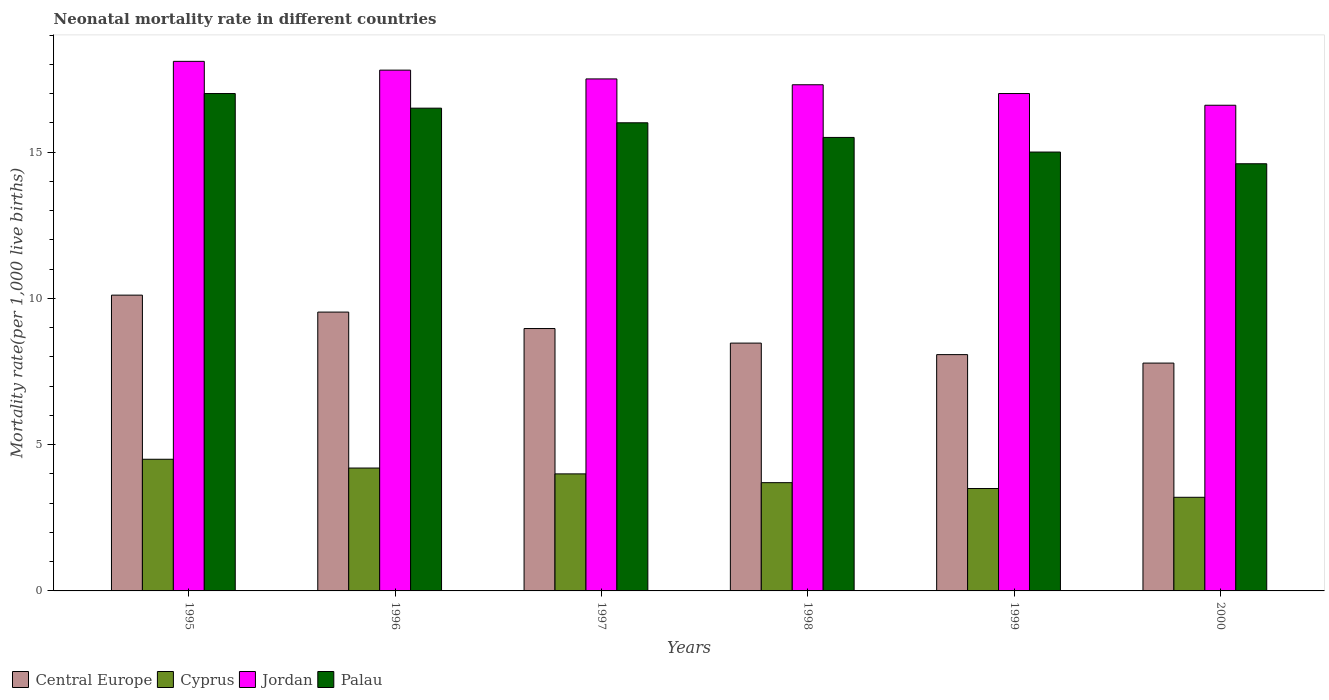How many different coloured bars are there?
Ensure brevity in your answer.  4. How many groups of bars are there?
Give a very brief answer. 6. Are the number of bars on each tick of the X-axis equal?
Make the answer very short. Yes. How many bars are there on the 6th tick from the left?
Provide a short and direct response. 4. What is the label of the 2nd group of bars from the left?
Provide a short and direct response. 1996. In how many cases, is the number of bars for a given year not equal to the number of legend labels?
Give a very brief answer. 0. What is the neonatal mortality rate in Jordan in 1999?
Make the answer very short. 17. Across all years, what is the minimum neonatal mortality rate in Jordan?
Your response must be concise. 16.6. In which year was the neonatal mortality rate in Jordan minimum?
Your answer should be very brief. 2000. What is the total neonatal mortality rate in Cyprus in the graph?
Provide a succinct answer. 23.1. What is the difference between the neonatal mortality rate in Palau in 1996 and that in 1997?
Offer a very short reply. 0.5. What is the difference between the neonatal mortality rate in Central Europe in 2000 and the neonatal mortality rate in Jordan in 1998?
Your answer should be compact. -9.51. What is the average neonatal mortality rate in Palau per year?
Keep it short and to the point. 15.77. In the year 2000, what is the difference between the neonatal mortality rate in Palau and neonatal mortality rate in Central Europe?
Offer a very short reply. 6.81. In how many years, is the neonatal mortality rate in Central Europe greater than 16?
Your answer should be compact. 0. What is the ratio of the neonatal mortality rate in Jordan in 1998 to that in 2000?
Your response must be concise. 1.04. Is the neonatal mortality rate in Cyprus in 1995 less than that in 1996?
Your answer should be compact. No. Is the difference between the neonatal mortality rate in Palau in 1999 and 2000 greater than the difference between the neonatal mortality rate in Central Europe in 1999 and 2000?
Your answer should be very brief. Yes. What is the difference between the highest and the second highest neonatal mortality rate in Palau?
Provide a succinct answer. 0.5. What is the difference between the highest and the lowest neonatal mortality rate in Palau?
Provide a succinct answer. 2.4. Is the sum of the neonatal mortality rate in Jordan in 1998 and 1999 greater than the maximum neonatal mortality rate in Cyprus across all years?
Offer a very short reply. Yes. Is it the case that in every year, the sum of the neonatal mortality rate in Cyprus and neonatal mortality rate in Central Europe is greater than the sum of neonatal mortality rate in Jordan and neonatal mortality rate in Palau?
Ensure brevity in your answer.  No. What does the 3rd bar from the left in 1998 represents?
Provide a succinct answer. Jordan. What does the 3rd bar from the right in 2000 represents?
Your answer should be compact. Cyprus. Is it the case that in every year, the sum of the neonatal mortality rate in Central Europe and neonatal mortality rate in Cyprus is greater than the neonatal mortality rate in Palau?
Offer a terse response. No. Are all the bars in the graph horizontal?
Make the answer very short. No. How many legend labels are there?
Offer a terse response. 4. What is the title of the graph?
Make the answer very short. Neonatal mortality rate in different countries. What is the label or title of the Y-axis?
Provide a short and direct response. Mortality rate(per 1,0 live births). What is the Mortality rate(per 1,000 live births) in Central Europe in 1995?
Provide a succinct answer. 10.11. What is the Mortality rate(per 1,000 live births) in Cyprus in 1995?
Provide a succinct answer. 4.5. What is the Mortality rate(per 1,000 live births) of Jordan in 1995?
Give a very brief answer. 18.1. What is the Mortality rate(per 1,000 live births) in Central Europe in 1996?
Your answer should be compact. 9.53. What is the Mortality rate(per 1,000 live births) of Jordan in 1996?
Make the answer very short. 17.8. What is the Mortality rate(per 1,000 live births) in Central Europe in 1997?
Offer a terse response. 8.97. What is the Mortality rate(per 1,000 live births) of Cyprus in 1997?
Provide a succinct answer. 4. What is the Mortality rate(per 1,000 live births) of Jordan in 1997?
Ensure brevity in your answer.  17.5. What is the Mortality rate(per 1,000 live births) of Palau in 1997?
Make the answer very short. 16. What is the Mortality rate(per 1,000 live births) of Central Europe in 1998?
Offer a terse response. 8.47. What is the Mortality rate(per 1,000 live births) in Cyprus in 1998?
Ensure brevity in your answer.  3.7. What is the Mortality rate(per 1,000 live births) of Jordan in 1998?
Your answer should be very brief. 17.3. What is the Mortality rate(per 1,000 live births) in Central Europe in 1999?
Your answer should be very brief. 8.08. What is the Mortality rate(per 1,000 live births) of Palau in 1999?
Your answer should be compact. 15. What is the Mortality rate(per 1,000 live births) of Central Europe in 2000?
Give a very brief answer. 7.79. What is the Mortality rate(per 1,000 live births) in Cyprus in 2000?
Your answer should be very brief. 3.2. What is the Mortality rate(per 1,000 live births) in Jordan in 2000?
Offer a terse response. 16.6. What is the Mortality rate(per 1,000 live births) in Palau in 2000?
Ensure brevity in your answer.  14.6. Across all years, what is the maximum Mortality rate(per 1,000 live births) of Central Europe?
Provide a succinct answer. 10.11. Across all years, what is the maximum Mortality rate(per 1,000 live births) in Palau?
Your answer should be compact. 17. Across all years, what is the minimum Mortality rate(per 1,000 live births) in Central Europe?
Give a very brief answer. 7.79. Across all years, what is the minimum Mortality rate(per 1,000 live births) in Palau?
Keep it short and to the point. 14.6. What is the total Mortality rate(per 1,000 live births) in Central Europe in the graph?
Provide a short and direct response. 52.94. What is the total Mortality rate(per 1,000 live births) in Cyprus in the graph?
Keep it short and to the point. 23.1. What is the total Mortality rate(per 1,000 live births) of Jordan in the graph?
Keep it short and to the point. 104.3. What is the total Mortality rate(per 1,000 live births) in Palau in the graph?
Your answer should be very brief. 94.6. What is the difference between the Mortality rate(per 1,000 live births) in Central Europe in 1995 and that in 1996?
Your answer should be very brief. 0.58. What is the difference between the Mortality rate(per 1,000 live births) of Cyprus in 1995 and that in 1996?
Your answer should be compact. 0.3. What is the difference between the Mortality rate(per 1,000 live births) of Palau in 1995 and that in 1996?
Provide a succinct answer. 0.5. What is the difference between the Mortality rate(per 1,000 live births) of Central Europe in 1995 and that in 1997?
Offer a terse response. 1.14. What is the difference between the Mortality rate(per 1,000 live births) in Cyprus in 1995 and that in 1997?
Your answer should be compact. 0.5. What is the difference between the Mortality rate(per 1,000 live births) of Jordan in 1995 and that in 1997?
Make the answer very short. 0.6. What is the difference between the Mortality rate(per 1,000 live births) in Palau in 1995 and that in 1997?
Make the answer very short. 1. What is the difference between the Mortality rate(per 1,000 live births) in Central Europe in 1995 and that in 1998?
Provide a short and direct response. 1.64. What is the difference between the Mortality rate(per 1,000 live births) in Cyprus in 1995 and that in 1998?
Make the answer very short. 0.8. What is the difference between the Mortality rate(per 1,000 live births) in Palau in 1995 and that in 1998?
Ensure brevity in your answer.  1.5. What is the difference between the Mortality rate(per 1,000 live births) of Central Europe in 1995 and that in 1999?
Your response must be concise. 2.03. What is the difference between the Mortality rate(per 1,000 live births) in Central Europe in 1995 and that in 2000?
Your response must be concise. 2.32. What is the difference between the Mortality rate(per 1,000 live births) of Cyprus in 1995 and that in 2000?
Your answer should be compact. 1.3. What is the difference between the Mortality rate(per 1,000 live births) of Jordan in 1995 and that in 2000?
Your answer should be very brief. 1.5. What is the difference between the Mortality rate(per 1,000 live births) of Central Europe in 1996 and that in 1997?
Ensure brevity in your answer.  0.56. What is the difference between the Mortality rate(per 1,000 live births) of Central Europe in 1996 and that in 1998?
Your answer should be very brief. 1.06. What is the difference between the Mortality rate(per 1,000 live births) in Cyprus in 1996 and that in 1998?
Provide a succinct answer. 0.5. What is the difference between the Mortality rate(per 1,000 live births) in Jordan in 1996 and that in 1998?
Give a very brief answer. 0.5. What is the difference between the Mortality rate(per 1,000 live births) of Central Europe in 1996 and that in 1999?
Your answer should be very brief. 1.45. What is the difference between the Mortality rate(per 1,000 live births) in Cyprus in 1996 and that in 1999?
Make the answer very short. 0.7. What is the difference between the Mortality rate(per 1,000 live births) of Jordan in 1996 and that in 1999?
Your answer should be compact. 0.8. What is the difference between the Mortality rate(per 1,000 live births) in Palau in 1996 and that in 1999?
Make the answer very short. 1.5. What is the difference between the Mortality rate(per 1,000 live births) of Central Europe in 1996 and that in 2000?
Offer a very short reply. 1.74. What is the difference between the Mortality rate(per 1,000 live births) of Jordan in 1996 and that in 2000?
Provide a succinct answer. 1.2. What is the difference between the Mortality rate(per 1,000 live births) of Central Europe in 1997 and that in 1998?
Keep it short and to the point. 0.5. What is the difference between the Mortality rate(per 1,000 live births) in Cyprus in 1997 and that in 1998?
Ensure brevity in your answer.  0.3. What is the difference between the Mortality rate(per 1,000 live births) in Jordan in 1997 and that in 1998?
Provide a short and direct response. 0.2. What is the difference between the Mortality rate(per 1,000 live births) in Palau in 1997 and that in 1998?
Your answer should be compact. 0.5. What is the difference between the Mortality rate(per 1,000 live births) in Central Europe in 1997 and that in 1999?
Provide a succinct answer. 0.89. What is the difference between the Mortality rate(per 1,000 live births) in Jordan in 1997 and that in 1999?
Your answer should be compact. 0.5. What is the difference between the Mortality rate(per 1,000 live births) of Central Europe in 1997 and that in 2000?
Keep it short and to the point. 1.18. What is the difference between the Mortality rate(per 1,000 live births) of Cyprus in 1997 and that in 2000?
Provide a short and direct response. 0.8. What is the difference between the Mortality rate(per 1,000 live births) of Palau in 1997 and that in 2000?
Keep it short and to the point. 1.4. What is the difference between the Mortality rate(per 1,000 live births) of Central Europe in 1998 and that in 1999?
Keep it short and to the point. 0.39. What is the difference between the Mortality rate(per 1,000 live births) of Cyprus in 1998 and that in 1999?
Provide a succinct answer. 0.2. What is the difference between the Mortality rate(per 1,000 live births) of Jordan in 1998 and that in 1999?
Your answer should be compact. 0.3. What is the difference between the Mortality rate(per 1,000 live births) in Central Europe in 1998 and that in 2000?
Ensure brevity in your answer.  0.68. What is the difference between the Mortality rate(per 1,000 live births) in Cyprus in 1998 and that in 2000?
Offer a very short reply. 0.5. What is the difference between the Mortality rate(per 1,000 live births) of Jordan in 1998 and that in 2000?
Provide a succinct answer. 0.7. What is the difference between the Mortality rate(per 1,000 live births) of Palau in 1998 and that in 2000?
Ensure brevity in your answer.  0.9. What is the difference between the Mortality rate(per 1,000 live births) of Central Europe in 1999 and that in 2000?
Make the answer very short. 0.29. What is the difference between the Mortality rate(per 1,000 live births) in Cyprus in 1999 and that in 2000?
Your answer should be very brief. 0.3. What is the difference between the Mortality rate(per 1,000 live births) in Jordan in 1999 and that in 2000?
Provide a succinct answer. 0.4. What is the difference between the Mortality rate(per 1,000 live births) of Central Europe in 1995 and the Mortality rate(per 1,000 live births) of Cyprus in 1996?
Give a very brief answer. 5.91. What is the difference between the Mortality rate(per 1,000 live births) in Central Europe in 1995 and the Mortality rate(per 1,000 live births) in Jordan in 1996?
Offer a terse response. -7.69. What is the difference between the Mortality rate(per 1,000 live births) in Central Europe in 1995 and the Mortality rate(per 1,000 live births) in Palau in 1996?
Offer a very short reply. -6.39. What is the difference between the Mortality rate(per 1,000 live births) in Cyprus in 1995 and the Mortality rate(per 1,000 live births) in Jordan in 1996?
Provide a short and direct response. -13.3. What is the difference between the Mortality rate(per 1,000 live births) in Cyprus in 1995 and the Mortality rate(per 1,000 live births) in Palau in 1996?
Make the answer very short. -12. What is the difference between the Mortality rate(per 1,000 live births) in Jordan in 1995 and the Mortality rate(per 1,000 live births) in Palau in 1996?
Your answer should be very brief. 1.6. What is the difference between the Mortality rate(per 1,000 live births) of Central Europe in 1995 and the Mortality rate(per 1,000 live births) of Cyprus in 1997?
Give a very brief answer. 6.11. What is the difference between the Mortality rate(per 1,000 live births) of Central Europe in 1995 and the Mortality rate(per 1,000 live births) of Jordan in 1997?
Ensure brevity in your answer.  -7.39. What is the difference between the Mortality rate(per 1,000 live births) of Central Europe in 1995 and the Mortality rate(per 1,000 live births) of Palau in 1997?
Give a very brief answer. -5.89. What is the difference between the Mortality rate(per 1,000 live births) of Central Europe in 1995 and the Mortality rate(per 1,000 live births) of Cyprus in 1998?
Offer a very short reply. 6.41. What is the difference between the Mortality rate(per 1,000 live births) of Central Europe in 1995 and the Mortality rate(per 1,000 live births) of Jordan in 1998?
Offer a terse response. -7.19. What is the difference between the Mortality rate(per 1,000 live births) of Central Europe in 1995 and the Mortality rate(per 1,000 live births) of Palau in 1998?
Offer a very short reply. -5.39. What is the difference between the Mortality rate(per 1,000 live births) of Cyprus in 1995 and the Mortality rate(per 1,000 live births) of Jordan in 1998?
Your answer should be compact. -12.8. What is the difference between the Mortality rate(per 1,000 live births) of Central Europe in 1995 and the Mortality rate(per 1,000 live births) of Cyprus in 1999?
Ensure brevity in your answer.  6.61. What is the difference between the Mortality rate(per 1,000 live births) in Central Europe in 1995 and the Mortality rate(per 1,000 live births) in Jordan in 1999?
Offer a very short reply. -6.89. What is the difference between the Mortality rate(per 1,000 live births) in Central Europe in 1995 and the Mortality rate(per 1,000 live births) in Palau in 1999?
Provide a short and direct response. -4.89. What is the difference between the Mortality rate(per 1,000 live births) of Cyprus in 1995 and the Mortality rate(per 1,000 live births) of Jordan in 1999?
Offer a very short reply. -12.5. What is the difference between the Mortality rate(per 1,000 live births) in Jordan in 1995 and the Mortality rate(per 1,000 live births) in Palau in 1999?
Keep it short and to the point. 3.1. What is the difference between the Mortality rate(per 1,000 live births) of Central Europe in 1995 and the Mortality rate(per 1,000 live births) of Cyprus in 2000?
Provide a short and direct response. 6.91. What is the difference between the Mortality rate(per 1,000 live births) in Central Europe in 1995 and the Mortality rate(per 1,000 live births) in Jordan in 2000?
Give a very brief answer. -6.49. What is the difference between the Mortality rate(per 1,000 live births) of Central Europe in 1995 and the Mortality rate(per 1,000 live births) of Palau in 2000?
Offer a terse response. -4.49. What is the difference between the Mortality rate(per 1,000 live births) of Cyprus in 1995 and the Mortality rate(per 1,000 live births) of Jordan in 2000?
Provide a succinct answer. -12.1. What is the difference between the Mortality rate(per 1,000 live births) in Jordan in 1995 and the Mortality rate(per 1,000 live births) in Palau in 2000?
Your answer should be compact. 3.5. What is the difference between the Mortality rate(per 1,000 live births) of Central Europe in 1996 and the Mortality rate(per 1,000 live births) of Cyprus in 1997?
Provide a short and direct response. 5.53. What is the difference between the Mortality rate(per 1,000 live births) in Central Europe in 1996 and the Mortality rate(per 1,000 live births) in Jordan in 1997?
Your response must be concise. -7.97. What is the difference between the Mortality rate(per 1,000 live births) of Central Europe in 1996 and the Mortality rate(per 1,000 live births) of Palau in 1997?
Your response must be concise. -6.47. What is the difference between the Mortality rate(per 1,000 live births) in Cyprus in 1996 and the Mortality rate(per 1,000 live births) in Jordan in 1997?
Offer a very short reply. -13.3. What is the difference between the Mortality rate(per 1,000 live births) of Cyprus in 1996 and the Mortality rate(per 1,000 live births) of Palau in 1997?
Keep it short and to the point. -11.8. What is the difference between the Mortality rate(per 1,000 live births) in Jordan in 1996 and the Mortality rate(per 1,000 live births) in Palau in 1997?
Provide a succinct answer. 1.8. What is the difference between the Mortality rate(per 1,000 live births) of Central Europe in 1996 and the Mortality rate(per 1,000 live births) of Cyprus in 1998?
Your answer should be compact. 5.83. What is the difference between the Mortality rate(per 1,000 live births) of Central Europe in 1996 and the Mortality rate(per 1,000 live births) of Jordan in 1998?
Offer a very short reply. -7.77. What is the difference between the Mortality rate(per 1,000 live births) in Central Europe in 1996 and the Mortality rate(per 1,000 live births) in Palau in 1998?
Your response must be concise. -5.97. What is the difference between the Mortality rate(per 1,000 live births) in Cyprus in 1996 and the Mortality rate(per 1,000 live births) in Palau in 1998?
Make the answer very short. -11.3. What is the difference between the Mortality rate(per 1,000 live births) of Central Europe in 1996 and the Mortality rate(per 1,000 live births) of Cyprus in 1999?
Make the answer very short. 6.03. What is the difference between the Mortality rate(per 1,000 live births) of Central Europe in 1996 and the Mortality rate(per 1,000 live births) of Jordan in 1999?
Ensure brevity in your answer.  -7.47. What is the difference between the Mortality rate(per 1,000 live births) in Central Europe in 1996 and the Mortality rate(per 1,000 live births) in Palau in 1999?
Ensure brevity in your answer.  -5.47. What is the difference between the Mortality rate(per 1,000 live births) of Jordan in 1996 and the Mortality rate(per 1,000 live births) of Palau in 1999?
Make the answer very short. 2.8. What is the difference between the Mortality rate(per 1,000 live births) in Central Europe in 1996 and the Mortality rate(per 1,000 live births) in Cyprus in 2000?
Give a very brief answer. 6.33. What is the difference between the Mortality rate(per 1,000 live births) of Central Europe in 1996 and the Mortality rate(per 1,000 live births) of Jordan in 2000?
Provide a succinct answer. -7.07. What is the difference between the Mortality rate(per 1,000 live births) of Central Europe in 1996 and the Mortality rate(per 1,000 live births) of Palau in 2000?
Your response must be concise. -5.07. What is the difference between the Mortality rate(per 1,000 live births) in Cyprus in 1996 and the Mortality rate(per 1,000 live births) in Jordan in 2000?
Offer a very short reply. -12.4. What is the difference between the Mortality rate(per 1,000 live births) of Jordan in 1996 and the Mortality rate(per 1,000 live births) of Palau in 2000?
Your answer should be very brief. 3.2. What is the difference between the Mortality rate(per 1,000 live births) of Central Europe in 1997 and the Mortality rate(per 1,000 live births) of Cyprus in 1998?
Your answer should be very brief. 5.27. What is the difference between the Mortality rate(per 1,000 live births) in Central Europe in 1997 and the Mortality rate(per 1,000 live births) in Jordan in 1998?
Make the answer very short. -8.33. What is the difference between the Mortality rate(per 1,000 live births) in Central Europe in 1997 and the Mortality rate(per 1,000 live births) in Palau in 1998?
Your answer should be very brief. -6.53. What is the difference between the Mortality rate(per 1,000 live births) of Cyprus in 1997 and the Mortality rate(per 1,000 live births) of Palau in 1998?
Make the answer very short. -11.5. What is the difference between the Mortality rate(per 1,000 live births) of Central Europe in 1997 and the Mortality rate(per 1,000 live births) of Cyprus in 1999?
Provide a short and direct response. 5.47. What is the difference between the Mortality rate(per 1,000 live births) in Central Europe in 1997 and the Mortality rate(per 1,000 live births) in Jordan in 1999?
Your answer should be very brief. -8.03. What is the difference between the Mortality rate(per 1,000 live births) in Central Europe in 1997 and the Mortality rate(per 1,000 live births) in Palau in 1999?
Offer a very short reply. -6.03. What is the difference between the Mortality rate(per 1,000 live births) in Cyprus in 1997 and the Mortality rate(per 1,000 live births) in Jordan in 1999?
Provide a short and direct response. -13. What is the difference between the Mortality rate(per 1,000 live births) in Cyprus in 1997 and the Mortality rate(per 1,000 live births) in Palau in 1999?
Offer a very short reply. -11. What is the difference between the Mortality rate(per 1,000 live births) of Jordan in 1997 and the Mortality rate(per 1,000 live births) of Palau in 1999?
Keep it short and to the point. 2.5. What is the difference between the Mortality rate(per 1,000 live births) of Central Europe in 1997 and the Mortality rate(per 1,000 live births) of Cyprus in 2000?
Keep it short and to the point. 5.77. What is the difference between the Mortality rate(per 1,000 live births) of Central Europe in 1997 and the Mortality rate(per 1,000 live births) of Jordan in 2000?
Ensure brevity in your answer.  -7.63. What is the difference between the Mortality rate(per 1,000 live births) in Central Europe in 1997 and the Mortality rate(per 1,000 live births) in Palau in 2000?
Offer a terse response. -5.63. What is the difference between the Mortality rate(per 1,000 live births) in Cyprus in 1997 and the Mortality rate(per 1,000 live births) in Jordan in 2000?
Ensure brevity in your answer.  -12.6. What is the difference between the Mortality rate(per 1,000 live births) of Cyprus in 1997 and the Mortality rate(per 1,000 live births) of Palau in 2000?
Offer a terse response. -10.6. What is the difference between the Mortality rate(per 1,000 live births) of Jordan in 1997 and the Mortality rate(per 1,000 live births) of Palau in 2000?
Provide a short and direct response. 2.9. What is the difference between the Mortality rate(per 1,000 live births) in Central Europe in 1998 and the Mortality rate(per 1,000 live births) in Cyprus in 1999?
Your response must be concise. 4.97. What is the difference between the Mortality rate(per 1,000 live births) of Central Europe in 1998 and the Mortality rate(per 1,000 live births) of Jordan in 1999?
Provide a succinct answer. -8.53. What is the difference between the Mortality rate(per 1,000 live births) in Central Europe in 1998 and the Mortality rate(per 1,000 live births) in Palau in 1999?
Give a very brief answer. -6.53. What is the difference between the Mortality rate(per 1,000 live births) of Central Europe in 1998 and the Mortality rate(per 1,000 live births) of Cyprus in 2000?
Your answer should be compact. 5.27. What is the difference between the Mortality rate(per 1,000 live births) of Central Europe in 1998 and the Mortality rate(per 1,000 live births) of Jordan in 2000?
Offer a very short reply. -8.13. What is the difference between the Mortality rate(per 1,000 live births) in Central Europe in 1998 and the Mortality rate(per 1,000 live births) in Palau in 2000?
Your answer should be compact. -6.13. What is the difference between the Mortality rate(per 1,000 live births) of Central Europe in 1999 and the Mortality rate(per 1,000 live births) of Cyprus in 2000?
Offer a terse response. 4.88. What is the difference between the Mortality rate(per 1,000 live births) of Central Europe in 1999 and the Mortality rate(per 1,000 live births) of Jordan in 2000?
Your response must be concise. -8.52. What is the difference between the Mortality rate(per 1,000 live births) in Central Europe in 1999 and the Mortality rate(per 1,000 live births) in Palau in 2000?
Your answer should be compact. -6.52. What is the difference between the Mortality rate(per 1,000 live births) in Cyprus in 1999 and the Mortality rate(per 1,000 live births) in Jordan in 2000?
Provide a succinct answer. -13.1. What is the difference between the Mortality rate(per 1,000 live births) in Jordan in 1999 and the Mortality rate(per 1,000 live births) in Palau in 2000?
Your answer should be compact. 2.4. What is the average Mortality rate(per 1,000 live births) of Central Europe per year?
Ensure brevity in your answer.  8.82. What is the average Mortality rate(per 1,000 live births) in Cyprus per year?
Give a very brief answer. 3.85. What is the average Mortality rate(per 1,000 live births) of Jordan per year?
Provide a succinct answer. 17.38. What is the average Mortality rate(per 1,000 live births) of Palau per year?
Offer a very short reply. 15.77. In the year 1995, what is the difference between the Mortality rate(per 1,000 live births) of Central Europe and Mortality rate(per 1,000 live births) of Cyprus?
Your answer should be very brief. 5.61. In the year 1995, what is the difference between the Mortality rate(per 1,000 live births) of Central Europe and Mortality rate(per 1,000 live births) of Jordan?
Keep it short and to the point. -7.99. In the year 1995, what is the difference between the Mortality rate(per 1,000 live births) in Central Europe and Mortality rate(per 1,000 live births) in Palau?
Your answer should be very brief. -6.89. In the year 1995, what is the difference between the Mortality rate(per 1,000 live births) in Cyprus and Mortality rate(per 1,000 live births) in Jordan?
Your response must be concise. -13.6. In the year 1995, what is the difference between the Mortality rate(per 1,000 live births) of Cyprus and Mortality rate(per 1,000 live births) of Palau?
Offer a terse response. -12.5. In the year 1995, what is the difference between the Mortality rate(per 1,000 live births) in Jordan and Mortality rate(per 1,000 live births) in Palau?
Offer a terse response. 1.1. In the year 1996, what is the difference between the Mortality rate(per 1,000 live births) in Central Europe and Mortality rate(per 1,000 live births) in Cyprus?
Make the answer very short. 5.33. In the year 1996, what is the difference between the Mortality rate(per 1,000 live births) of Central Europe and Mortality rate(per 1,000 live births) of Jordan?
Provide a short and direct response. -8.27. In the year 1996, what is the difference between the Mortality rate(per 1,000 live births) in Central Europe and Mortality rate(per 1,000 live births) in Palau?
Your answer should be very brief. -6.97. In the year 1996, what is the difference between the Mortality rate(per 1,000 live births) of Jordan and Mortality rate(per 1,000 live births) of Palau?
Provide a succinct answer. 1.3. In the year 1997, what is the difference between the Mortality rate(per 1,000 live births) in Central Europe and Mortality rate(per 1,000 live births) in Cyprus?
Offer a terse response. 4.97. In the year 1997, what is the difference between the Mortality rate(per 1,000 live births) in Central Europe and Mortality rate(per 1,000 live births) in Jordan?
Provide a succinct answer. -8.53. In the year 1997, what is the difference between the Mortality rate(per 1,000 live births) in Central Europe and Mortality rate(per 1,000 live births) in Palau?
Your answer should be very brief. -7.03. In the year 1997, what is the difference between the Mortality rate(per 1,000 live births) in Cyprus and Mortality rate(per 1,000 live births) in Jordan?
Your answer should be very brief. -13.5. In the year 1997, what is the difference between the Mortality rate(per 1,000 live births) in Cyprus and Mortality rate(per 1,000 live births) in Palau?
Your response must be concise. -12. In the year 1998, what is the difference between the Mortality rate(per 1,000 live births) of Central Europe and Mortality rate(per 1,000 live births) of Cyprus?
Your response must be concise. 4.77. In the year 1998, what is the difference between the Mortality rate(per 1,000 live births) of Central Europe and Mortality rate(per 1,000 live births) of Jordan?
Give a very brief answer. -8.83. In the year 1998, what is the difference between the Mortality rate(per 1,000 live births) of Central Europe and Mortality rate(per 1,000 live births) of Palau?
Your answer should be very brief. -7.03. In the year 1998, what is the difference between the Mortality rate(per 1,000 live births) in Cyprus and Mortality rate(per 1,000 live births) in Palau?
Your response must be concise. -11.8. In the year 1998, what is the difference between the Mortality rate(per 1,000 live births) in Jordan and Mortality rate(per 1,000 live births) in Palau?
Offer a very short reply. 1.8. In the year 1999, what is the difference between the Mortality rate(per 1,000 live births) in Central Europe and Mortality rate(per 1,000 live births) in Cyprus?
Offer a terse response. 4.58. In the year 1999, what is the difference between the Mortality rate(per 1,000 live births) of Central Europe and Mortality rate(per 1,000 live births) of Jordan?
Ensure brevity in your answer.  -8.92. In the year 1999, what is the difference between the Mortality rate(per 1,000 live births) in Central Europe and Mortality rate(per 1,000 live births) in Palau?
Ensure brevity in your answer.  -6.92. In the year 1999, what is the difference between the Mortality rate(per 1,000 live births) of Cyprus and Mortality rate(per 1,000 live births) of Jordan?
Offer a very short reply. -13.5. In the year 1999, what is the difference between the Mortality rate(per 1,000 live births) in Cyprus and Mortality rate(per 1,000 live births) in Palau?
Your response must be concise. -11.5. In the year 2000, what is the difference between the Mortality rate(per 1,000 live births) in Central Europe and Mortality rate(per 1,000 live births) in Cyprus?
Your response must be concise. 4.59. In the year 2000, what is the difference between the Mortality rate(per 1,000 live births) in Central Europe and Mortality rate(per 1,000 live births) in Jordan?
Make the answer very short. -8.81. In the year 2000, what is the difference between the Mortality rate(per 1,000 live births) of Central Europe and Mortality rate(per 1,000 live births) of Palau?
Give a very brief answer. -6.81. In the year 2000, what is the difference between the Mortality rate(per 1,000 live births) of Jordan and Mortality rate(per 1,000 live births) of Palau?
Your answer should be compact. 2. What is the ratio of the Mortality rate(per 1,000 live births) of Central Europe in 1995 to that in 1996?
Provide a short and direct response. 1.06. What is the ratio of the Mortality rate(per 1,000 live births) in Cyprus in 1995 to that in 1996?
Offer a very short reply. 1.07. What is the ratio of the Mortality rate(per 1,000 live births) in Jordan in 1995 to that in 1996?
Your answer should be very brief. 1.02. What is the ratio of the Mortality rate(per 1,000 live births) in Palau in 1995 to that in 1996?
Make the answer very short. 1.03. What is the ratio of the Mortality rate(per 1,000 live births) of Central Europe in 1995 to that in 1997?
Provide a succinct answer. 1.13. What is the ratio of the Mortality rate(per 1,000 live births) of Cyprus in 1995 to that in 1997?
Your response must be concise. 1.12. What is the ratio of the Mortality rate(per 1,000 live births) in Jordan in 1995 to that in 1997?
Your answer should be very brief. 1.03. What is the ratio of the Mortality rate(per 1,000 live births) in Palau in 1995 to that in 1997?
Give a very brief answer. 1.06. What is the ratio of the Mortality rate(per 1,000 live births) in Central Europe in 1995 to that in 1998?
Your answer should be very brief. 1.19. What is the ratio of the Mortality rate(per 1,000 live births) in Cyprus in 1995 to that in 1998?
Your answer should be compact. 1.22. What is the ratio of the Mortality rate(per 1,000 live births) of Jordan in 1995 to that in 1998?
Offer a terse response. 1.05. What is the ratio of the Mortality rate(per 1,000 live births) of Palau in 1995 to that in 1998?
Your answer should be compact. 1.1. What is the ratio of the Mortality rate(per 1,000 live births) of Central Europe in 1995 to that in 1999?
Provide a short and direct response. 1.25. What is the ratio of the Mortality rate(per 1,000 live births) in Jordan in 1995 to that in 1999?
Offer a terse response. 1.06. What is the ratio of the Mortality rate(per 1,000 live births) of Palau in 1995 to that in 1999?
Make the answer very short. 1.13. What is the ratio of the Mortality rate(per 1,000 live births) of Central Europe in 1995 to that in 2000?
Offer a very short reply. 1.3. What is the ratio of the Mortality rate(per 1,000 live births) of Cyprus in 1995 to that in 2000?
Provide a succinct answer. 1.41. What is the ratio of the Mortality rate(per 1,000 live births) in Jordan in 1995 to that in 2000?
Offer a very short reply. 1.09. What is the ratio of the Mortality rate(per 1,000 live births) in Palau in 1995 to that in 2000?
Offer a very short reply. 1.16. What is the ratio of the Mortality rate(per 1,000 live births) of Central Europe in 1996 to that in 1997?
Offer a terse response. 1.06. What is the ratio of the Mortality rate(per 1,000 live births) of Cyprus in 1996 to that in 1997?
Provide a short and direct response. 1.05. What is the ratio of the Mortality rate(per 1,000 live births) in Jordan in 1996 to that in 1997?
Provide a short and direct response. 1.02. What is the ratio of the Mortality rate(per 1,000 live births) in Palau in 1996 to that in 1997?
Provide a succinct answer. 1.03. What is the ratio of the Mortality rate(per 1,000 live births) of Central Europe in 1996 to that in 1998?
Your answer should be very brief. 1.13. What is the ratio of the Mortality rate(per 1,000 live births) of Cyprus in 1996 to that in 1998?
Provide a short and direct response. 1.14. What is the ratio of the Mortality rate(per 1,000 live births) of Jordan in 1996 to that in 1998?
Provide a succinct answer. 1.03. What is the ratio of the Mortality rate(per 1,000 live births) in Palau in 1996 to that in 1998?
Offer a terse response. 1.06. What is the ratio of the Mortality rate(per 1,000 live births) of Central Europe in 1996 to that in 1999?
Your answer should be very brief. 1.18. What is the ratio of the Mortality rate(per 1,000 live births) in Cyprus in 1996 to that in 1999?
Your answer should be compact. 1.2. What is the ratio of the Mortality rate(per 1,000 live births) of Jordan in 1996 to that in 1999?
Make the answer very short. 1.05. What is the ratio of the Mortality rate(per 1,000 live births) in Central Europe in 1996 to that in 2000?
Your response must be concise. 1.22. What is the ratio of the Mortality rate(per 1,000 live births) of Cyprus in 1996 to that in 2000?
Provide a short and direct response. 1.31. What is the ratio of the Mortality rate(per 1,000 live births) of Jordan in 1996 to that in 2000?
Your response must be concise. 1.07. What is the ratio of the Mortality rate(per 1,000 live births) in Palau in 1996 to that in 2000?
Offer a very short reply. 1.13. What is the ratio of the Mortality rate(per 1,000 live births) of Central Europe in 1997 to that in 1998?
Your response must be concise. 1.06. What is the ratio of the Mortality rate(per 1,000 live births) of Cyprus in 1997 to that in 1998?
Your answer should be compact. 1.08. What is the ratio of the Mortality rate(per 1,000 live births) of Jordan in 1997 to that in 1998?
Your answer should be compact. 1.01. What is the ratio of the Mortality rate(per 1,000 live births) of Palau in 1997 to that in 1998?
Your answer should be compact. 1.03. What is the ratio of the Mortality rate(per 1,000 live births) of Central Europe in 1997 to that in 1999?
Offer a very short reply. 1.11. What is the ratio of the Mortality rate(per 1,000 live births) of Cyprus in 1997 to that in 1999?
Your answer should be very brief. 1.14. What is the ratio of the Mortality rate(per 1,000 live births) in Jordan in 1997 to that in 1999?
Give a very brief answer. 1.03. What is the ratio of the Mortality rate(per 1,000 live births) of Palau in 1997 to that in 1999?
Your response must be concise. 1.07. What is the ratio of the Mortality rate(per 1,000 live births) of Central Europe in 1997 to that in 2000?
Ensure brevity in your answer.  1.15. What is the ratio of the Mortality rate(per 1,000 live births) of Cyprus in 1997 to that in 2000?
Your answer should be compact. 1.25. What is the ratio of the Mortality rate(per 1,000 live births) in Jordan in 1997 to that in 2000?
Offer a terse response. 1.05. What is the ratio of the Mortality rate(per 1,000 live births) in Palau in 1997 to that in 2000?
Ensure brevity in your answer.  1.1. What is the ratio of the Mortality rate(per 1,000 live births) in Central Europe in 1998 to that in 1999?
Provide a succinct answer. 1.05. What is the ratio of the Mortality rate(per 1,000 live births) of Cyprus in 1998 to that in 1999?
Your answer should be very brief. 1.06. What is the ratio of the Mortality rate(per 1,000 live births) in Jordan in 1998 to that in 1999?
Keep it short and to the point. 1.02. What is the ratio of the Mortality rate(per 1,000 live births) of Central Europe in 1998 to that in 2000?
Keep it short and to the point. 1.09. What is the ratio of the Mortality rate(per 1,000 live births) of Cyprus in 1998 to that in 2000?
Your answer should be compact. 1.16. What is the ratio of the Mortality rate(per 1,000 live births) in Jordan in 1998 to that in 2000?
Provide a short and direct response. 1.04. What is the ratio of the Mortality rate(per 1,000 live births) in Palau in 1998 to that in 2000?
Give a very brief answer. 1.06. What is the ratio of the Mortality rate(per 1,000 live births) of Central Europe in 1999 to that in 2000?
Offer a very short reply. 1.04. What is the ratio of the Mortality rate(per 1,000 live births) of Cyprus in 1999 to that in 2000?
Give a very brief answer. 1.09. What is the ratio of the Mortality rate(per 1,000 live births) in Jordan in 1999 to that in 2000?
Ensure brevity in your answer.  1.02. What is the ratio of the Mortality rate(per 1,000 live births) in Palau in 1999 to that in 2000?
Make the answer very short. 1.03. What is the difference between the highest and the second highest Mortality rate(per 1,000 live births) in Central Europe?
Offer a very short reply. 0.58. What is the difference between the highest and the lowest Mortality rate(per 1,000 live births) in Central Europe?
Give a very brief answer. 2.32. What is the difference between the highest and the lowest Mortality rate(per 1,000 live births) of Cyprus?
Provide a short and direct response. 1.3. What is the difference between the highest and the lowest Mortality rate(per 1,000 live births) of Palau?
Offer a terse response. 2.4. 